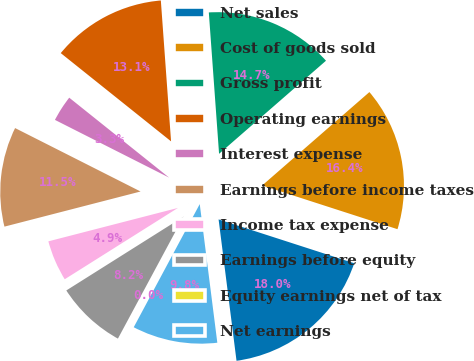Convert chart. <chart><loc_0><loc_0><loc_500><loc_500><pie_chart><fcel>Net sales<fcel>Cost of goods sold<fcel>Gross profit<fcel>Operating earnings<fcel>Interest expense<fcel>Earnings before income taxes<fcel>Income tax expense<fcel>Earnings before equity<fcel>Equity earnings net of tax<fcel>Net earnings<nl><fcel>18.02%<fcel>16.38%<fcel>14.75%<fcel>13.11%<fcel>3.29%<fcel>11.47%<fcel>4.93%<fcel>8.2%<fcel>0.02%<fcel>9.84%<nl></chart> 